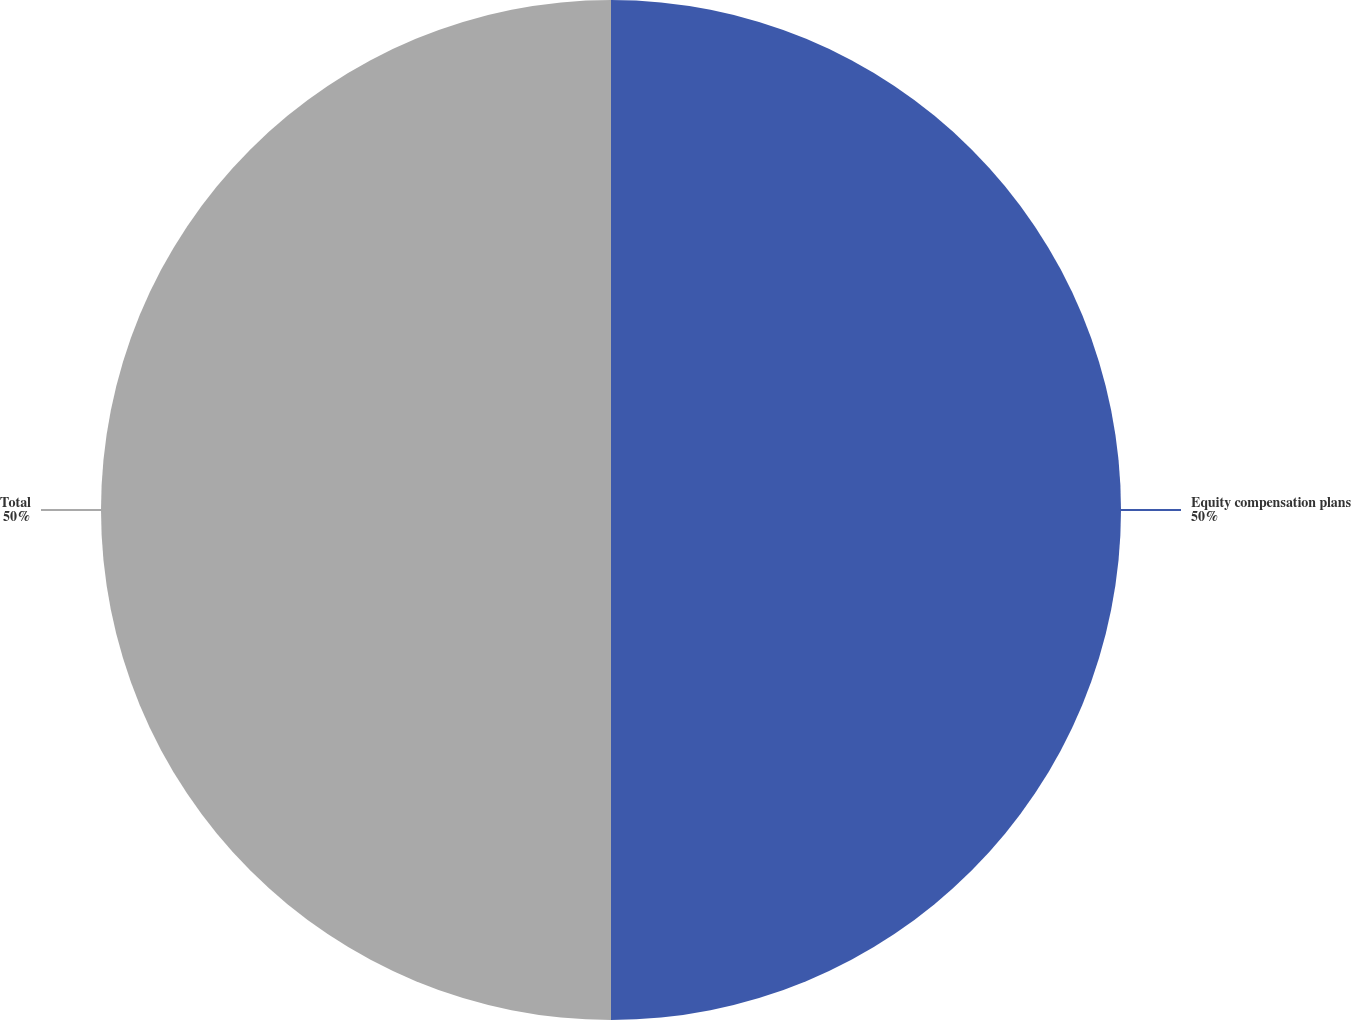<chart> <loc_0><loc_0><loc_500><loc_500><pie_chart><fcel>Equity compensation plans<fcel>Total<nl><fcel>50.0%<fcel>50.0%<nl></chart> 